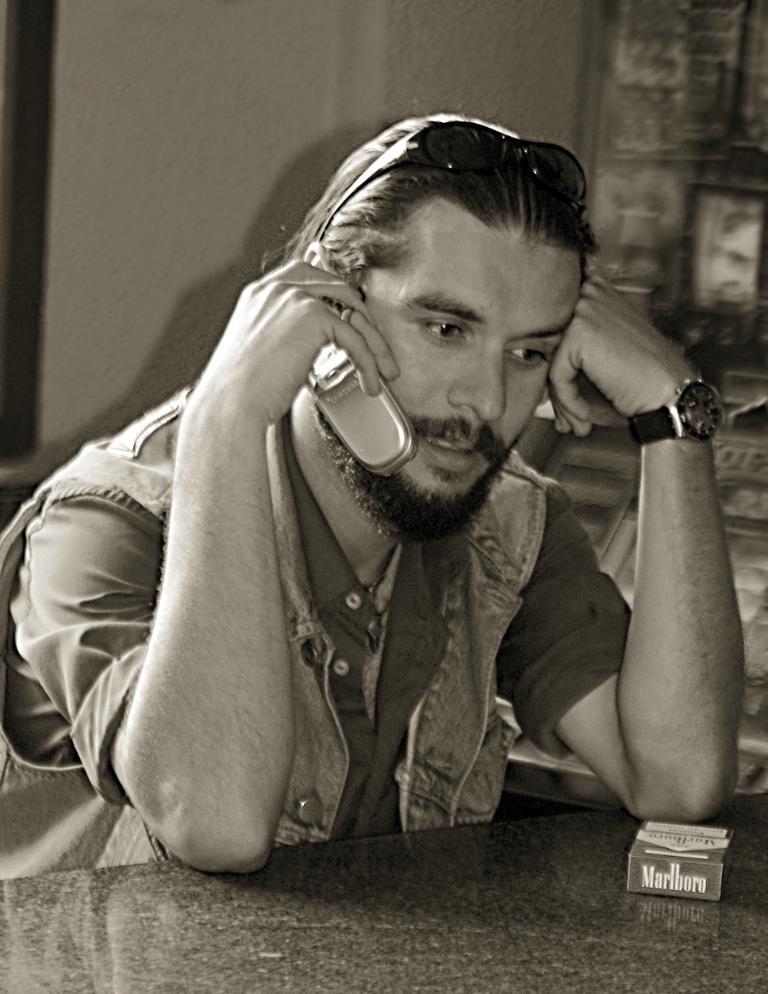Describe this image in one or two sentences. In the center of the image we can see a man sitting and holding a phone, before him there is a table. In the background there is a wall. 